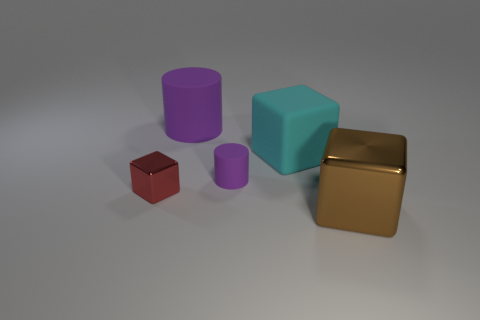Add 1 big purple matte objects. How many objects exist? 6 Subtract all cylinders. How many objects are left? 3 Add 4 cyan rubber things. How many cyan rubber things are left? 5 Add 1 small purple rubber objects. How many small purple rubber objects exist? 2 Subtract 0 yellow balls. How many objects are left? 5 Subtract all blue matte cylinders. Subtract all purple objects. How many objects are left? 3 